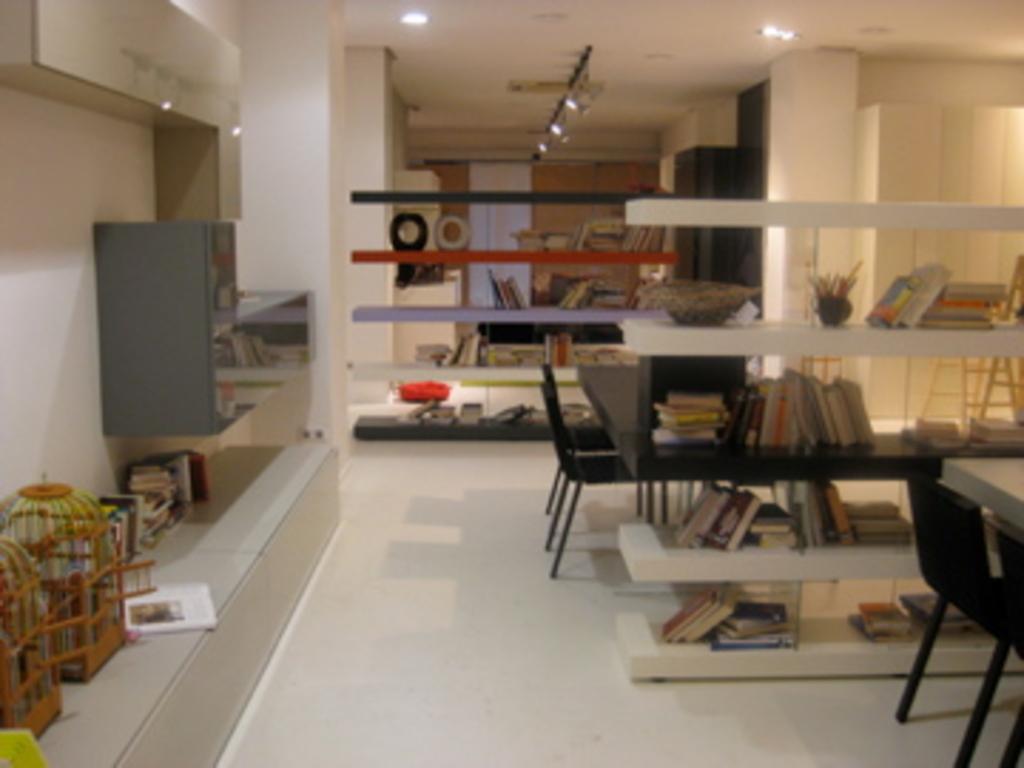Describe this image in one or two sentences. This is an inside view of a room. In the middle of the image there are few racks in which many books are placed. On the left side there are two wooden cages and some books are placed. In the the background there are few pillar and a wall. At the top there are few lights. On the right side I can see few empty chairs on the floor. 